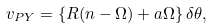Convert formula to latex. <formula><loc_0><loc_0><loc_500><loc_500>v _ { P Y } = \left \{ R ( n - \Omega ) + a \Omega \right \} \delta \theta ,</formula> 